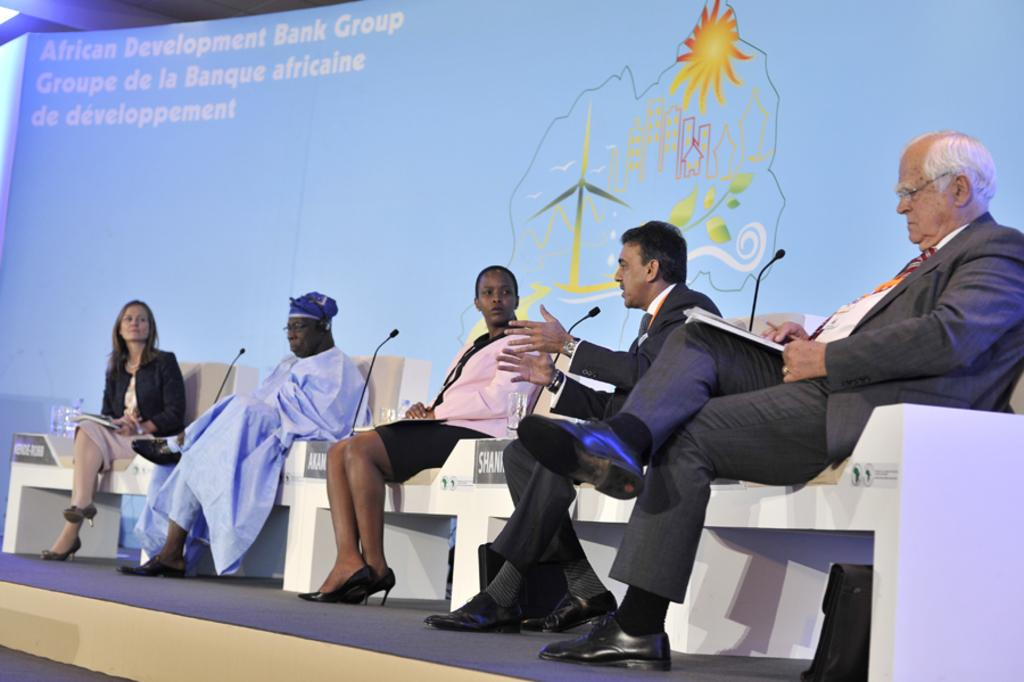What is happening in the image? There is a group of people in the image, and they are sitting on a stage. What can be seen on the chairs of the people? There are names on the chairs of the people. What is located behind the people on the stage? There is a banner with text behind the people. Can you see a woman holding a hammer in the image? There is no woman holding a hammer in the image. Is there a goat present on the stage with the group of people? There is no goat present in the image. 